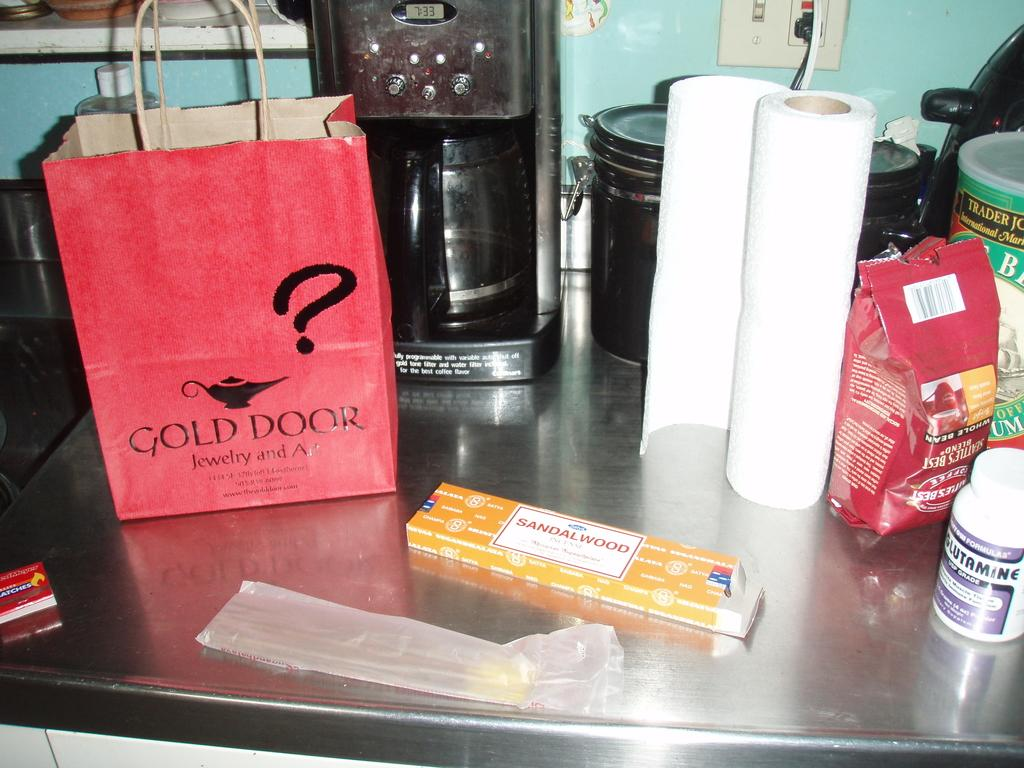<image>
Describe the image concisely. On the counters there is a bottle of glutamine, Seattles Best coffee and a bag from Gold Door Jewlery. 